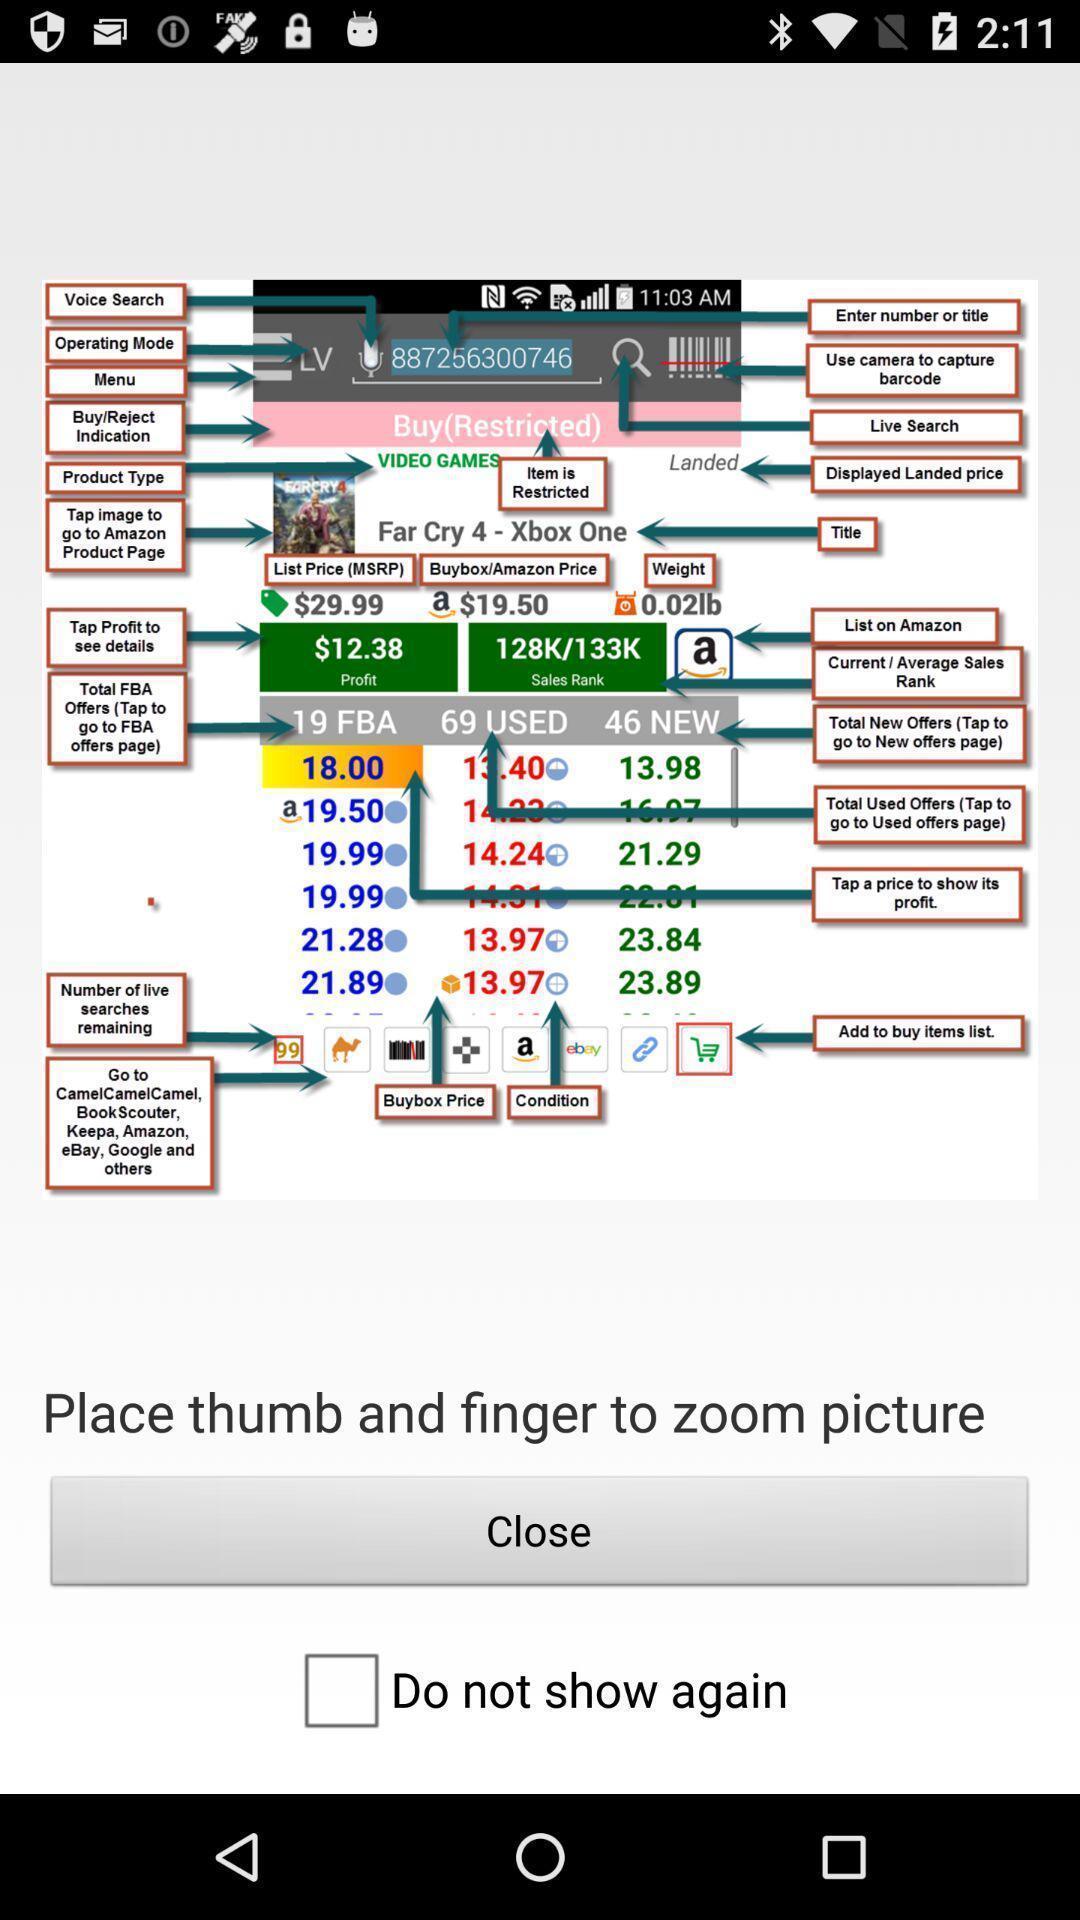Give me a summary of this screen capture. Screen displaying demo instructions to access an application. 